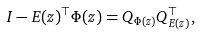Convert formula to latex. <formula><loc_0><loc_0><loc_500><loc_500>I - E ( z ) ^ { \top } \Phi ( z ) = Q _ { \Phi ( z ) } Q _ { E ( z ) } ^ { \top } ,</formula> 